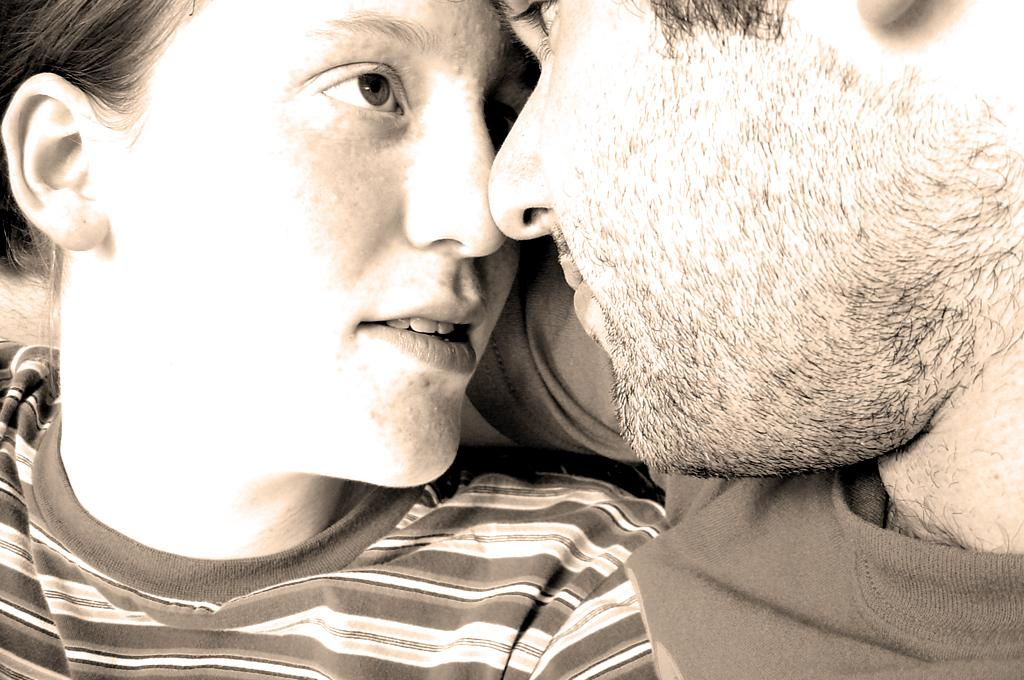How many people are in the image? There are two people in the image, a woman and a man. What are the people wearing in the image? Both the woman and the man are wearing t-shirts in the image. What is the color scheme of the image? The image has a predominantly brown and white color scheme. What type of card game are the people playing in the image? There is no card game present in the image; it only features a woman and a man wearing t-shirts. Is the image set during the night? The provided facts do not mention the time of day, so it cannot be determined if the image is set during the night. 